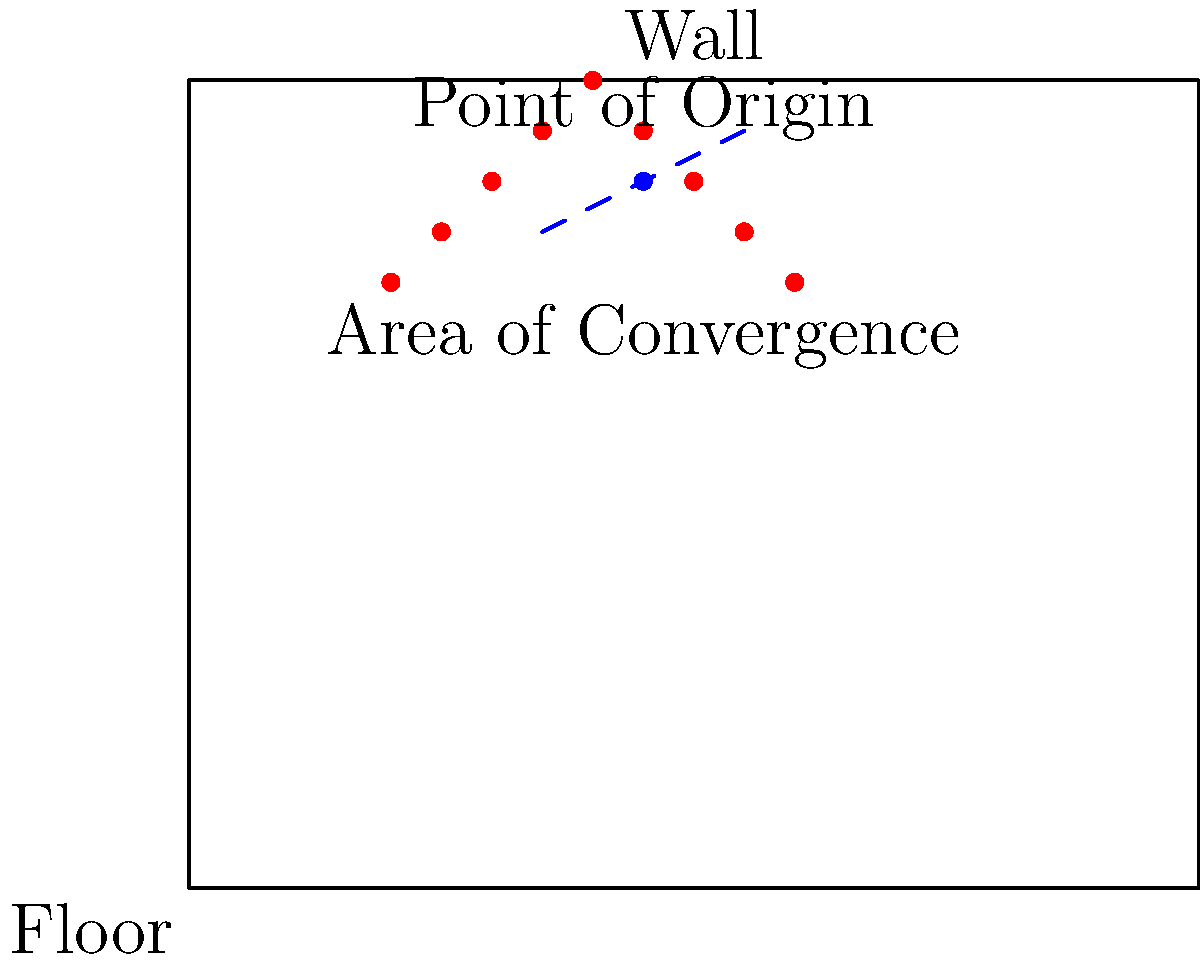In the given crime scene sketch, what can be inferred about the victim's position based on the blood spatter pattern, and how might this information be crucial for your defense strategy? To analyze this blood spatter pattern and its implications for the defense strategy, we need to consider the following steps:

1. Identify the pattern: The blood spatter forms an elongated, elliptical shape, suggesting a medium to high-velocity impact spatter.

2. Locate the area of convergence: This is where the blood droplets appear to intersect if their paths are traced backwards. In the sketch, it's indicated by the dashed blue line.

3. Determine the point of origin: This is the approximate location in three-dimensional space where the blood source was when the spatter was created. It's marked by the blue dot slightly above the area of convergence.

4. Interpret the findings:
   a) The location of the point of origin suggests that the blood source (likely the victim) was positioned slightly elevated from the floor, possibly sitting or kneeling.
   b) The direction of the spatter indicates that the force causing the blood distribution came from a direction perpendicular to the wall.

5. Apply to defense strategy:
   a) If the prosecution's theory conflicts with this blood spatter analysis, it could be used to cast doubt on their reconstruction of events.
   b) The elevated point of origin might suggest a scenario where the victim was not standing, which could support various defense narratives (e.g., a struggle, self-defense, or accidental injury).
   c) The pattern's consistency with medium to high-velocity impact could indicate the use of a specific type of weapon or force, which might be relevant to the charges or the defendant's account of events.

6. Consult with the retired FBI agent:
   a) Verify the interpretation of the blood spatter pattern.
   b) Discuss possible alternative scenarios that could produce such a pattern.
   c) Explore how this evidence might be presented effectively in court to support the defense's case.

By understanding and effectively presenting this blood spatter evidence, the defense can potentially challenge the prosecution's version of events and create reasonable doubt in the minds of the jury.
Answer: Victim likely in elevated position; crucial for challenging prosecution's scenario and supporting alternative defense narratives. 